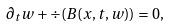Convert formula to latex. <formula><loc_0><loc_0><loc_500><loc_500>\partial _ { t } w + \div ( B ( x , t , w ) ) = 0 ,</formula> 